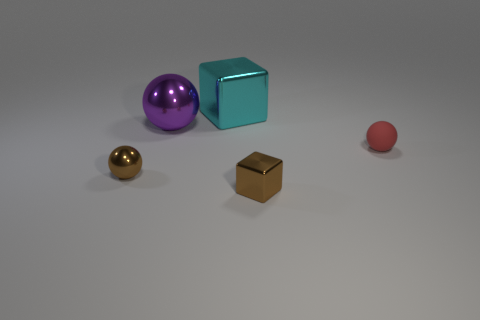There is a small shiny thing that is the same color as the tiny cube; what is its shape?
Make the answer very short. Sphere. What shape is the large object behind the big purple shiny sphere?
Give a very brief answer. Cube. What is the shape of the object to the right of the shiny block in front of the brown ball?
Keep it short and to the point. Sphere. Are there any other small shiny objects that have the same shape as the cyan shiny thing?
Give a very brief answer. Yes. What shape is the red object that is the same size as the brown metallic sphere?
Make the answer very short. Sphere. There is a large object on the right side of the large shiny object in front of the cyan object; are there any big objects to the right of it?
Your answer should be very brief. No. Are there any metallic spheres that have the same size as the red thing?
Offer a terse response. Yes. There is a brown object that is to the right of the small brown shiny ball; what is its size?
Your response must be concise. Small. What color is the object that is on the right side of the brown object that is on the right side of the block that is to the left of the brown shiny block?
Offer a very short reply. Red. There is a block that is in front of the block behind the small red rubber sphere; what color is it?
Your response must be concise. Brown. 